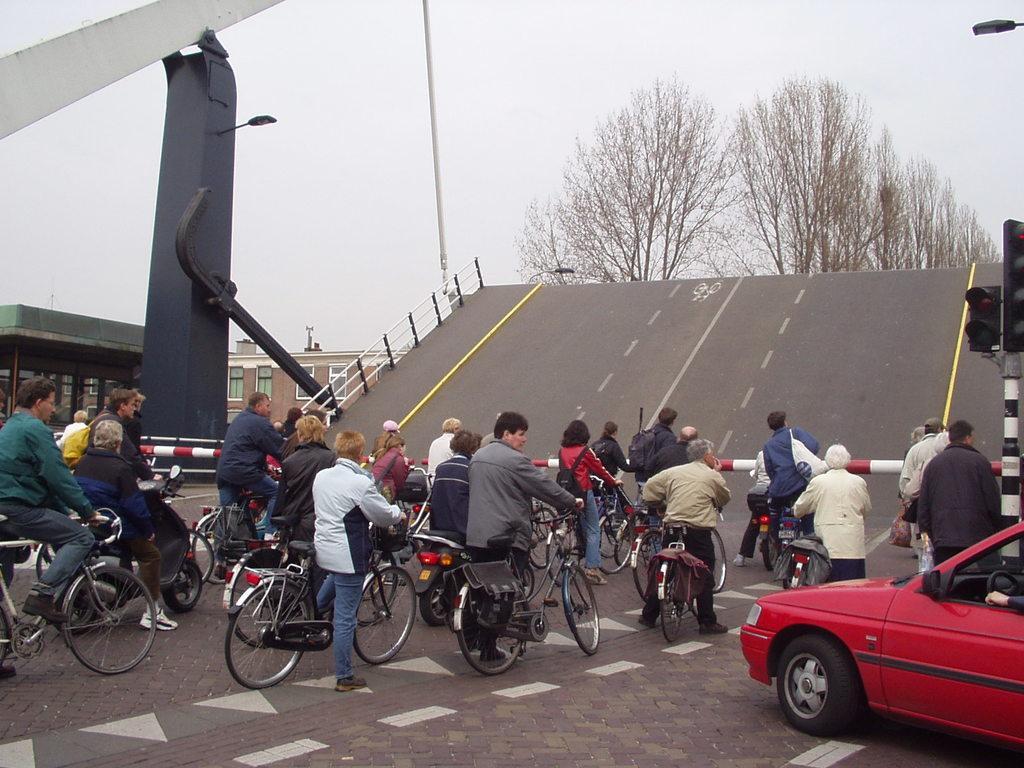Describe this image in one or two sentences. There are some persons on the road with their bicycle. This is a car which is in red color. This is road. There is a building and on the background we can see sky and these are the trees. There is a traffic signal and this is light. 